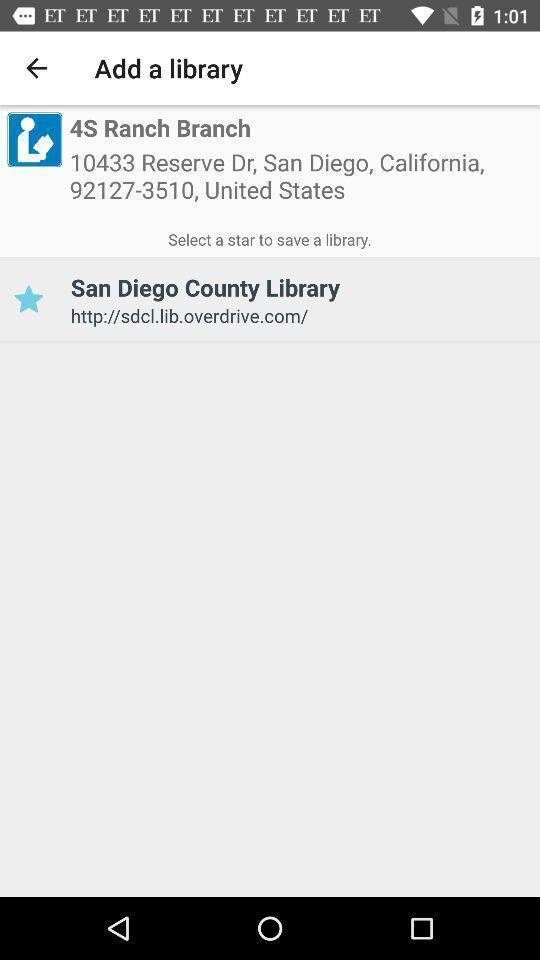What is the overall content of this screenshot? Screen showing address of a library. 